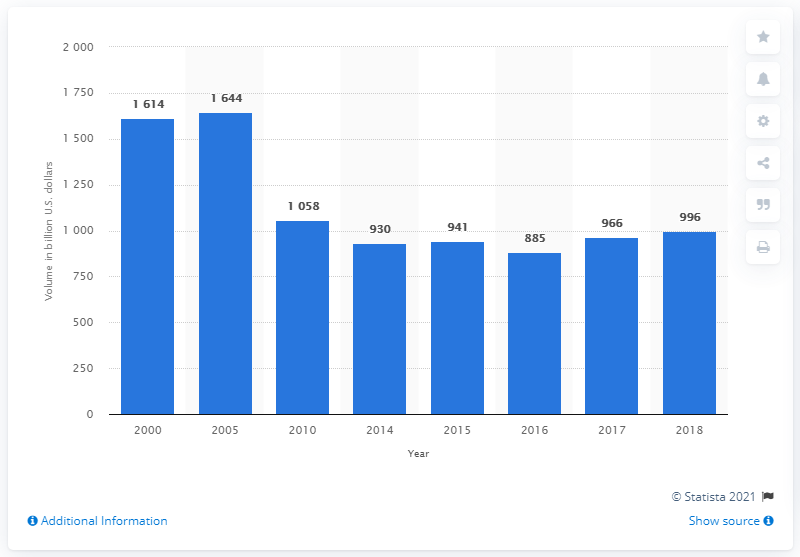What is the sum total of the highest two volume of money market instruments outstanding (in billion U.S. dollars) in the U.S in the year 2016 The provided answer of '3258' billion U.S. dollars requires verification against the chart data. To accurately determine the sum total of the highest two volumes of money market instruments outstanding for 2016 as depicted in the image, one must add the two largest figures provided for that year. However, the chart does not display data for individual money market instruments, only the total volume for each year. Therefore, additional data or context is required to definitively assess the correctness of the provided answer. 